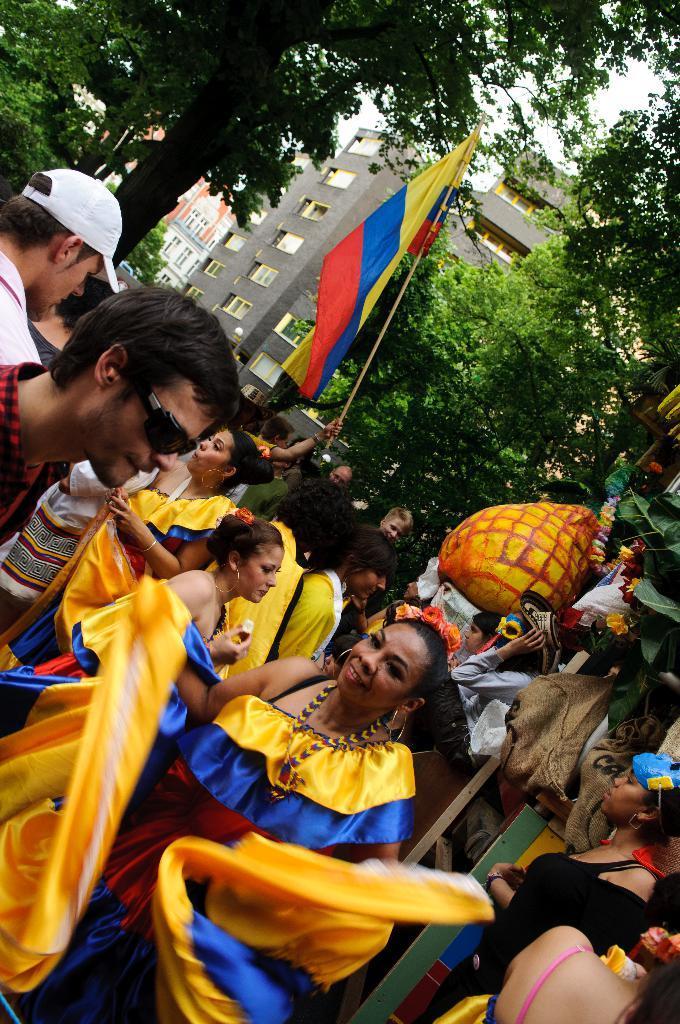Can you describe this image briefly? At the bottom of the image few people are standing and holding a flag. At the top of the image there are some trees and buildings. 